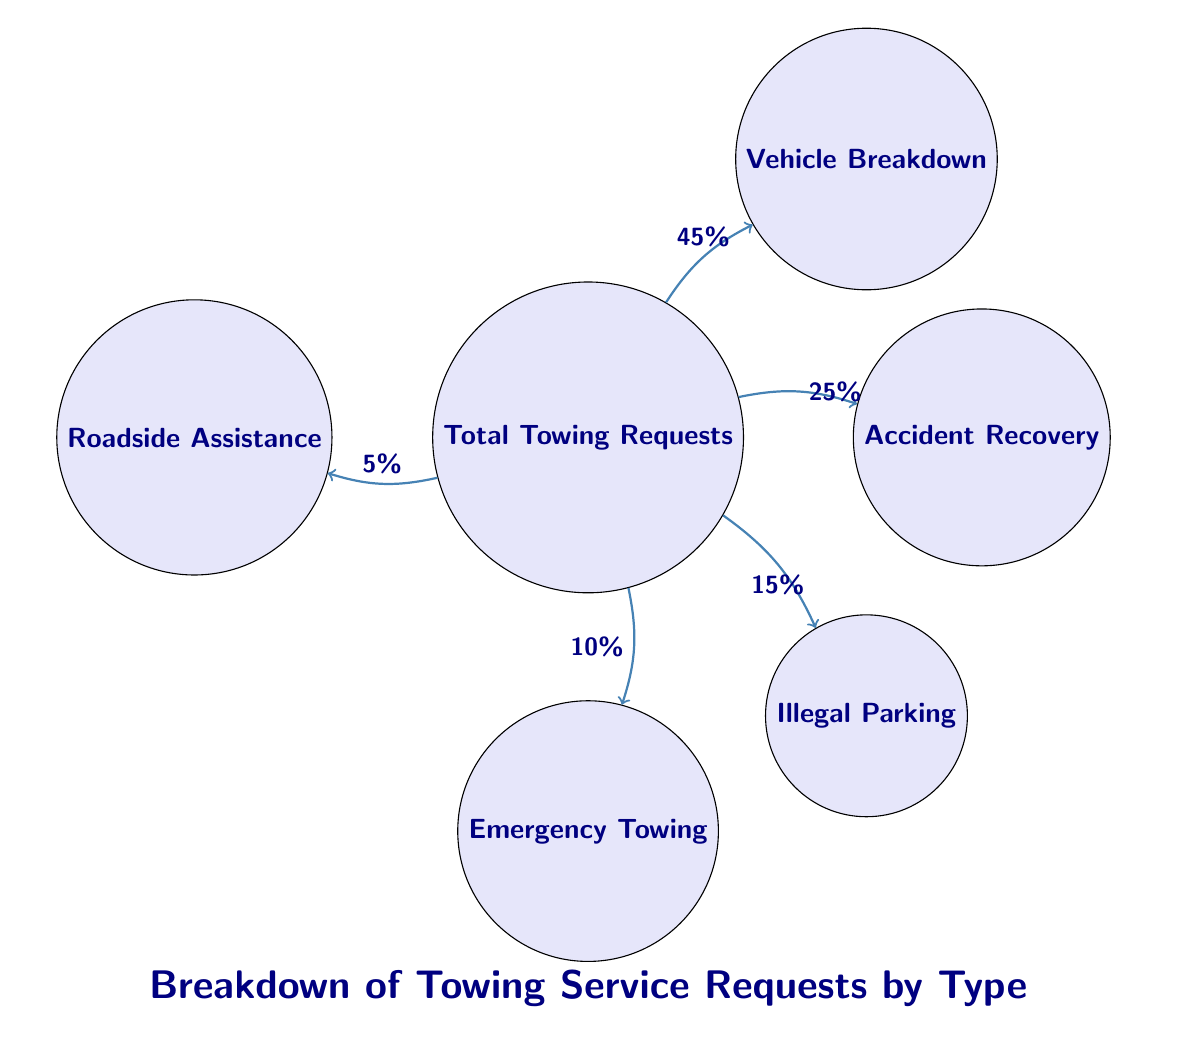What percentage of towing requests are for vehicle breakdown? The node for 'Vehicle Breakdown' has a directed edge from the 'Total Towing Requests' node with a label indicating the percentage. This label shows '45%', which represents the proportion of total requests attributed to vehicle breakdown.
Answer: 45% What type of towing service has the least requests? By examining the nodes, the 'Roadside Assistance' node is positioned with a directed edge from the 'Total Towing Requests' node labeled '5%', making it the type with the least requests overall.
Answer: Roadside Assistance How many types of towing services are represented in the diagram? To find the number of different service types, count the unique nodes connected to the 'Total Towing Requests' node. There are five nodes representing different types: Vehicle Breakdown, Accident Recovery, Illegal Parking, Emergency Towing, and Roadside Assistance.
Answer: 5 Which type of towing service has a higher percentage, Accident Recovery or Emergency Towing? Comparing the directed edges from 'Total Towing Requests', 'Accident Recovery' has a labeled edge of '25%' and 'Emergency Towing' has '10%'. Since '25%' is greater than '10%', Accident Recovery has a higher percentage.
Answer: Accident Recovery What is the total percentage shown for all towing service types combined? To find the total percentage, we sum the percentages shown on all the edges leading from 'Total Towing Requests': 45% (Vehicle Breakdown) + 25% (Accident Recovery) + 15% (Illegal Parking) + 10% (Emergency Towing) + 5% (Roadside Assistance). This combination results in a total of 100%.
Answer: 100% Which towing service type falls in the middle of the percentage range? The percentages for the services in ascending order are: 5% (Roadside Assistance), 10% (Emergency Towing), 15% (Illegal Parking), 25% (Accident Recovery), and 45% (Vehicle Breakdown). The middle value in this list is '15%', corresponding to 'Illegal Parking'.
Answer: Illegal Parking 